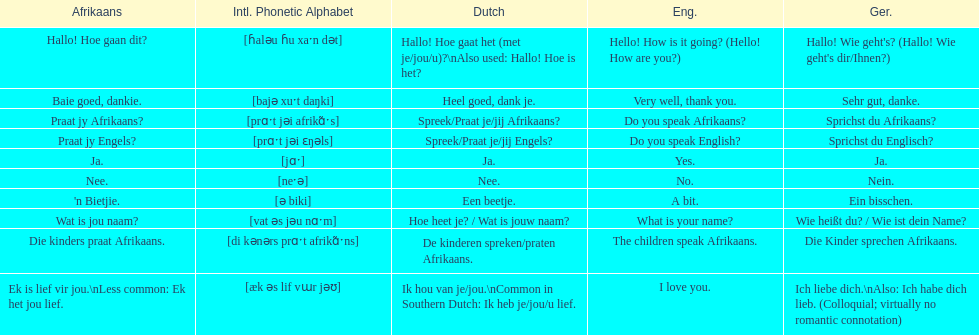Parse the table in full. {'header': ['Afrikaans', 'Intl. Phonetic Alphabet', 'Dutch', 'Eng.', 'Ger.'], 'rows': [['Hallo! Hoe gaan dit?', '[ɦaləu ɦu xaˑn dət]', 'Hallo! Hoe gaat het (met je/jou/u)?\\nAlso used: Hallo! Hoe is het?', 'Hello! How is it going? (Hello! How are you?)', "Hallo! Wie geht's? (Hallo! Wie geht's dir/Ihnen?)"], ['Baie goed, dankie.', '[bajə xuˑt daŋki]', 'Heel goed, dank je.', 'Very well, thank you.', 'Sehr gut, danke.'], ['Praat jy Afrikaans?', '[prɑˑt jəi afrikɑ̃ˑs]', 'Spreek/Praat je/jij Afrikaans?', 'Do you speak Afrikaans?', 'Sprichst du Afrikaans?'], ['Praat jy Engels?', '[prɑˑt jəi ɛŋəls]', 'Spreek/Praat je/jij Engels?', 'Do you speak English?', 'Sprichst du Englisch?'], ['Ja.', '[jɑˑ]', 'Ja.', 'Yes.', 'Ja.'], ['Nee.', '[neˑə]', 'Nee.', 'No.', 'Nein.'], ["'n Bietjie.", '[ə biki]', 'Een beetje.', 'A bit.', 'Ein bisschen.'], ['Wat is jou naam?', '[vat əs jəu nɑˑm]', 'Hoe heet je? / Wat is jouw naam?', 'What is your name?', 'Wie heißt du? / Wie ist dein Name?'], ['Die kinders praat Afrikaans.', '[di kənərs prɑˑt afrikɑ̃ˑns]', 'De kinderen spreken/praten Afrikaans.', 'The children speak Afrikaans.', 'Die Kinder sprechen Afrikaans.'], ['Ek is lief vir jou.\\nLess common: Ek het jou lief.', '[æk əs lif vɯr jəʊ]', 'Ik hou van je/jou.\\nCommon in Southern Dutch: Ik heb je/jou/u lief.', 'I love you.', 'Ich liebe dich.\\nAlso: Ich habe dich lieb. (Colloquial; virtually no romantic connotation)']]} How do you say 'yes' in afrikaans? Ja. 